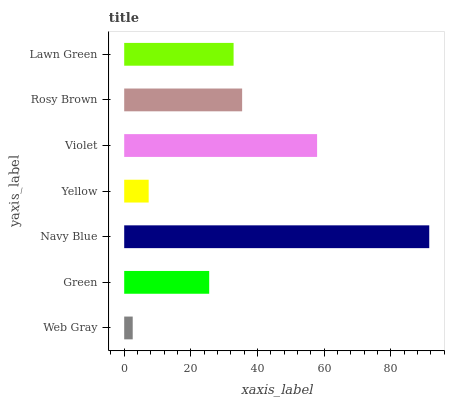Is Web Gray the minimum?
Answer yes or no. Yes. Is Navy Blue the maximum?
Answer yes or no. Yes. Is Green the minimum?
Answer yes or no. No. Is Green the maximum?
Answer yes or no. No. Is Green greater than Web Gray?
Answer yes or no. Yes. Is Web Gray less than Green?
Answer yes or no. Yes. Is Web Gray greater than Green?
Answer yes or no. No. Is Green less than Web Gray?
Answer yes or no. No. Is Lawn Green the high median?
Answer yes or no. Yes. Is Lawn Green the low median?
Answer yes or no. Yes. Is Green the high median?
Answer yes or no. No. Is Yellow the low median?
Answer yes or no. No. 